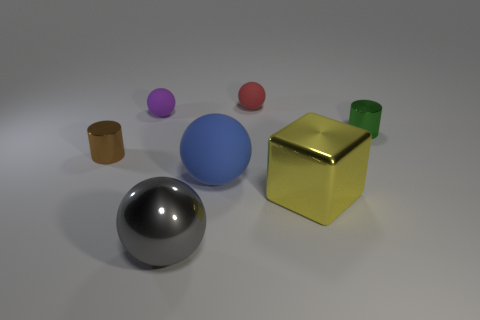There is a purple object that is the same size as the green metallic cylinder; what shape is it?
Your response must be concise. Sphere. What is the shape of the large gray object that is the same material as the yellow object?
Provide a short and direct response. Sphere. There is a tiny cylinder that is on the right side of the large metal cube that is in front of the cylinder right of the gray thing; what color is it?
Offer a very short reply. Green. Are there any metallic cylinders behind the purple rubber thing that is behind the gray metallic ball?
Offer a terse response. No. Is the color of the big metallic object left of the red matte object the same as the small metallic cylinder that is to the left of the shiny block?
Keep it short and to the point. No. What number of red rubber spheres are the same size as the purple thing?
Your answer should be compact. 1. There is a metal cylinder right of the red ball; does it have the same size as the tiny red thing?
Your answer should be very brief. Yes. The red matte thing has what shape?
Your answer should be compact. Sphere. Is the cylinder on the right side of the red thing made of the same material as the small purple thing?
Make the answer very short. No. Are there any cylinders that have the same color as the big rubber object?
Keep it short and to the point. No. 